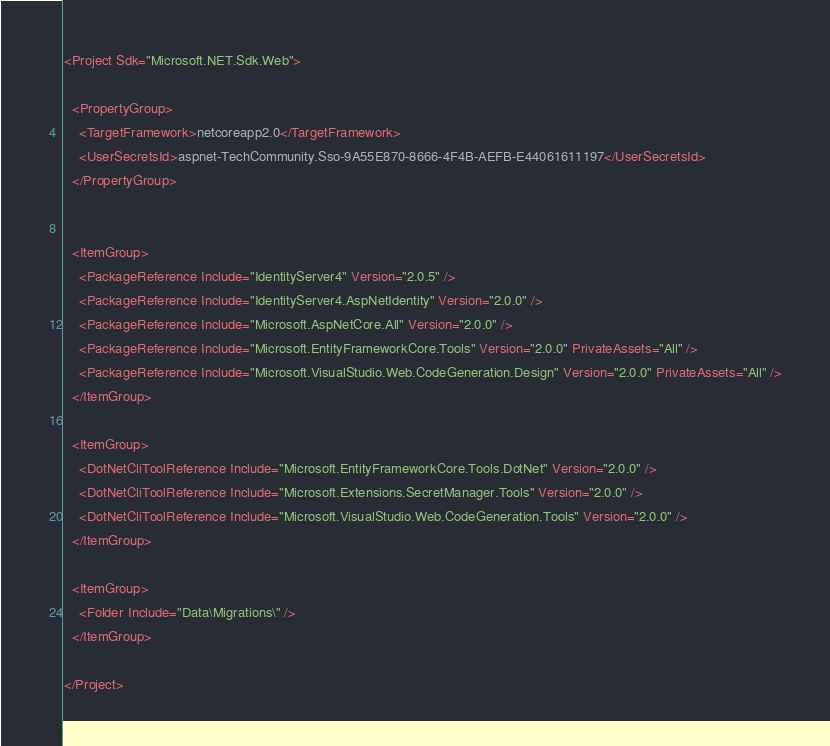Convert code to text. <code><loc_0><loc_0><loc_500><loc_500><_XML_><Project Sdk="Microsoft.NET.Sdk.Web">

  <PropertyGroup>
    <TargetFramework>netcoreapp2.0</TargetFramework>
    <UserSecretsId>aspnet-TechCommunity.Sso-9A55E870-8666-4F4B-AEFB-E44061611197</UserSecretsId>
  </PropertyGroup>


  <ItemGroup>
    <PackageReference Include="IdentityServer4" Version="2.0.5" />
    <PackageReference Include="IdentityServer4.AspNetIdentity" Version="2.0.0" />
    <PackageReference Include="Microsoft.AspNetCore.All" Version="2.0.0" />
    <PackageReference Include="Microsoft.EntityFrameworkCore.Tools" Version="2.0.0" PrivateAssets="All" />
    <PackageReference Include="Microsoft.VisualStudio.Web.CodeGeneration.Design" Version="2.0.0" PrivateAssets="All" />
  </ItemGroup>

  <ItemGroup>
    <DotNetCliToolReference Include="Microsoft.EntityFrameworkCore.Tools.DotNet" Version="2.0.0" />
    <DotNetCliToolReference Include="Microsoft.Extensions.SecretManager.Tools" Version="2.0.0" />
    <DotNetCliToolReference Include="Microsoft.VisualStudio.Web.CodeGeneration.Tools" Version="2.0.0" />
  </ItemGroup>

  <ItemGroup>
    <Folder Include="Data\Migrations\" />
  </ItemGroup>

</Project>
</code> 